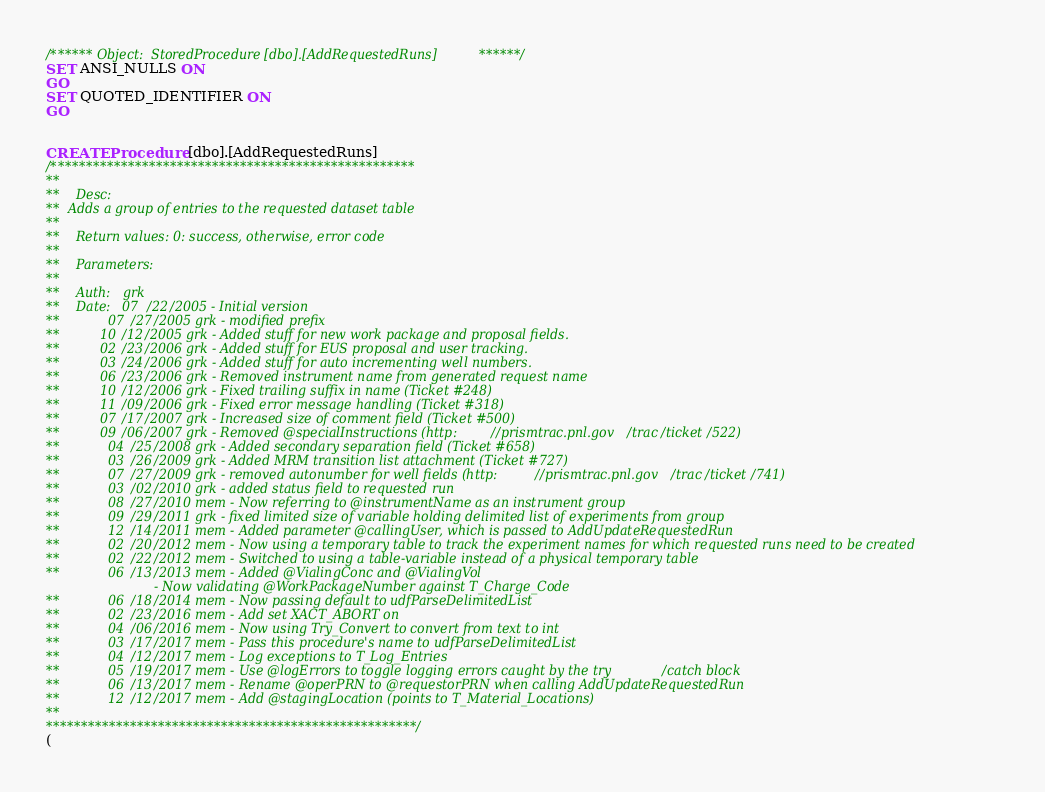<code> <loc_0><loc_0><loc_500><loc_500><_SQL_>/****** Object:  StoredProcedure [dbo].[AddRequestedRuns] ******/
SET ANSI_NULLS ON
GO
SET QUOTED_IDENTIFIER ON
GO


CREATE Procedure [dbo].[AddRequestedRuns]
/****************************************************
**
**	Desc: 
**  Adds a group of entries to the requested dataset table
**
**	Return values: 0: success, otherwise, error code
**
**	Parameters: 
**
**	Auth:	grk
**	Date:	07/22/2005 - Initial version
**			07/27/2005 grk - modified prefix
**          10/12/2005 grk - Added stuff for new work package and proposal fields.
**          02/23/2006 grk - Added stuff for EUS proposal and user tracking.
**          03/24/2006 grk - Added stuff for auto incrementing well numbers.
**          06/23/2006 grk - Removed instrument name from generated request name
**          10/12/2006 grk - Fixed trailing suffix in name (Ticket #248)
**          11/09/2006 grk - Fixed error message handling (Ticket #318)
**          07/17/2007 grk - Increased size of comment field (Ticket #500)
**          09/06/2007 grk - Removed @specialInstructions (http://prismtrac.pnl.gov/trac/ticket/522)
**			04/25/2008 grk - Added secondary separation field (Ticket #658)
**			03/26/2009 grk - Added MRM transition list attachment (Ticket #727)
**			07/27/2009 grk - removed autonumber for well fields (http://prismtrac.pnl.gov/trac/ticket/741)
**			03/02/2010 grk - added status field to requested run
**			08/27/2010 mem - Now referring to @instrumentName as an instrument group
**			09/29/2011 grk - fixed limited size of variable holding delimited list of experiments from group
**			12/14/2011 mem - Added parameter @callingUser, which is passed to AddUpdateRequestedRun
**			02/20/2012 mem - Now using a temporary table to track the experiment names for which requested runs need to be created
**			02/22/2012 mem - Switched to using a table-variable instead of a physical temporary table
**			06/13/2013 mem - Added @VialingConc and @VialingVol
						   - Now validating @WorkPackageNumber against T_Charge_Code
**			06/18/2014 mem - Now passing default to udfParseDelimitedList
**			02/23/2016 mem - Add set XACT_ABORT on
**			04/06/2016 mem - Now using Try_Convert to convert from text to int
**			03/17/2017 mem - Pass this procedure's name to udfParseDelimitedList
**			04/12/2017 mem - Log exceptions to T_Log_Entries
**			05/19/2017 mem - Use @logErrors to toggle logging errors caught by the try/catch block
**			06/13/2017 mem - Rename @operPRN to @requestorPRN when calling AddUpdateRequestedRun
**			12/12/2017 mem - Add @stagingLocation (points to T_Material_Locations)
**
*****************************************************/
(</code> 